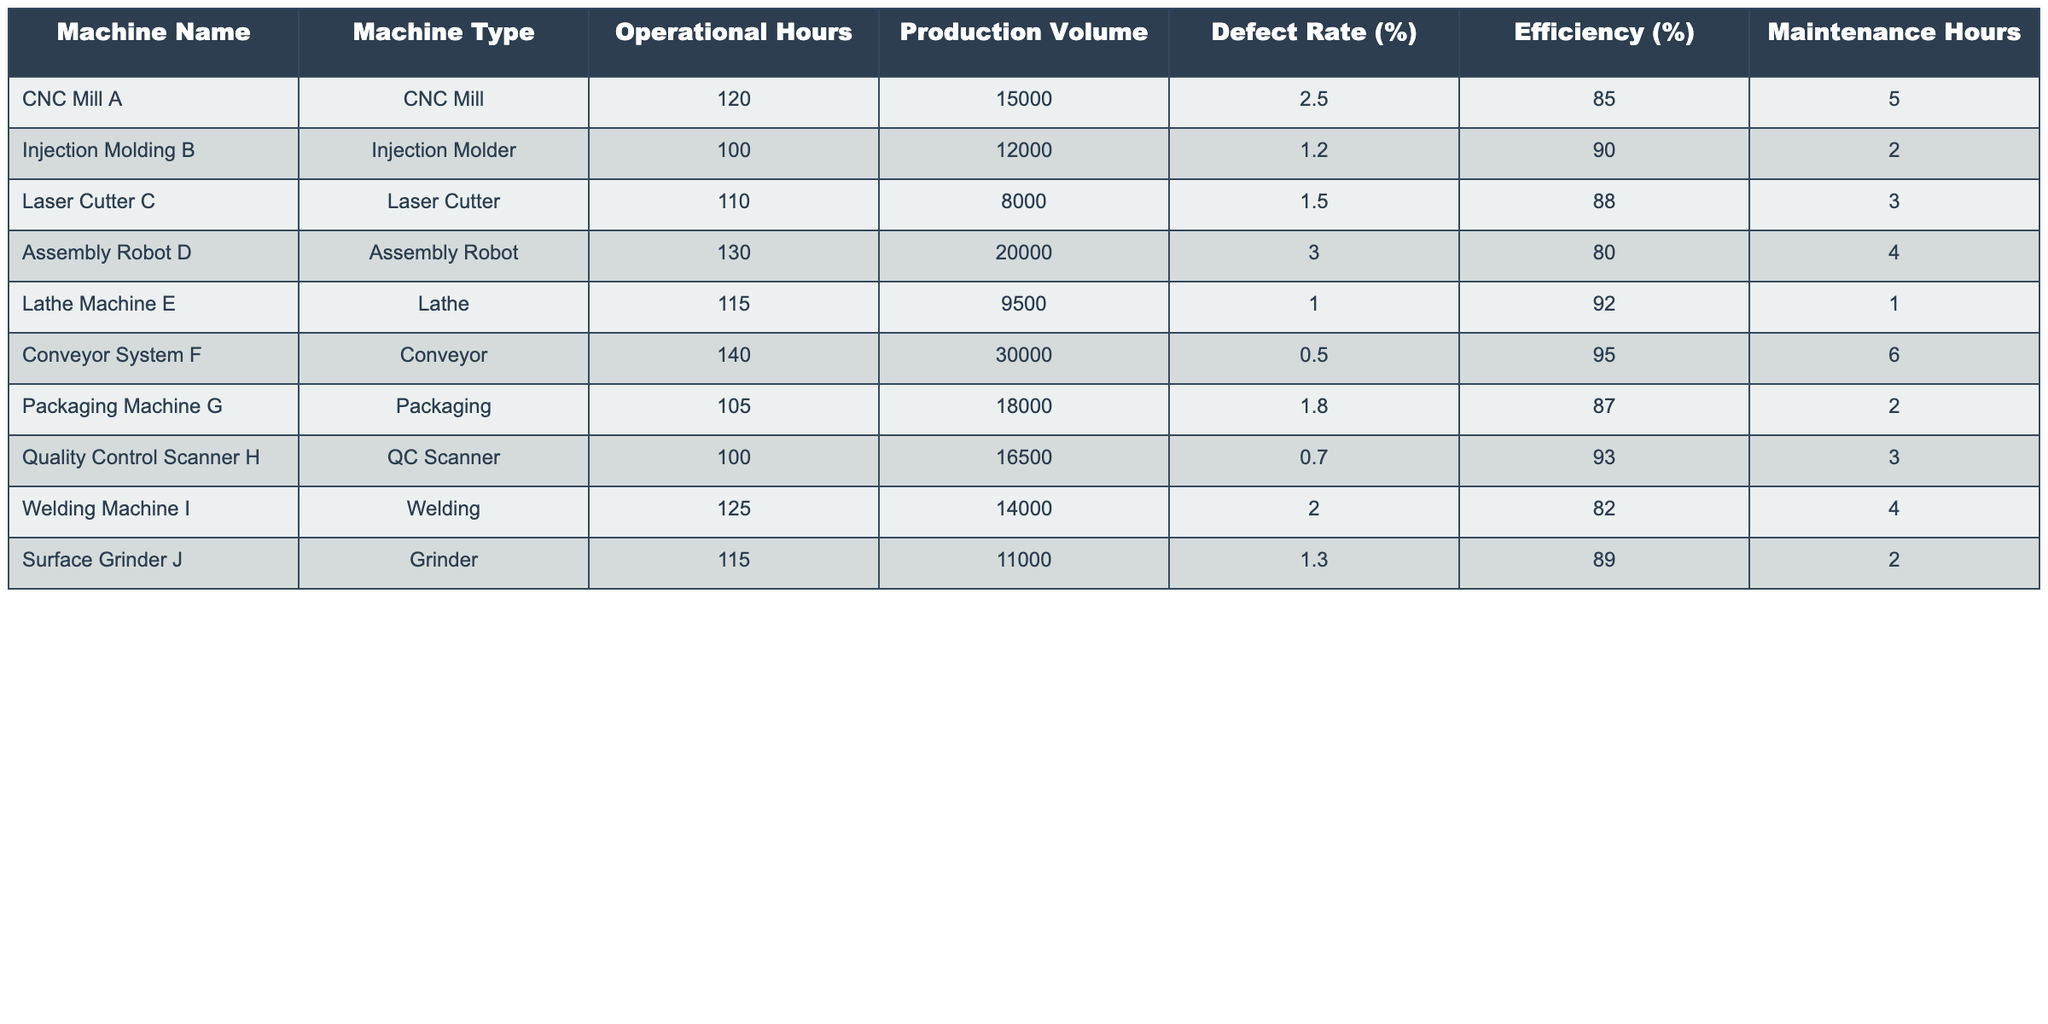What is the Efficiency percentage of the Conveyor System F? According to the table, the Efficiency percentage of Conveyor System F is listed directly under the Efficiency (%) column. It shows 95%.
Answer: 95% Which machine has the highest Production Volume? By looking at the Production Volume column, Conveyor System F has the highest production value of 30,000 units compared to the others.
Answer: Conveyor System F What is the average Defect Rate of all machines on the production line? The Defect Rates are: 2.5, 1.2, 1.5, 3.0, 1.0, 0.5, 1.8, 0.7, 2.0, 1.3. Summing these gives 16.5. There are 10 machines, so the average is 16.5/10 = 1.65%.
Answer: 1.65% Is the Defect Rate of Lathe Machine E lower than the average Defect Rate? The Defect Rate for Lathe Machine E is 1.0%. From the previous question, the average Defect Rate is 1.65%, and since 1.0% is less than 1.65%, the statement is true.
Answer: Yes Which machine uses the most Maintenance Hours? Looking at the Maintenance Hours column, the Conveyor System F has the highest value of 6 hours among all machines.
Answer: Conveyor System F If you compare the average Efficiency of CNC Mill A and Injection Molding B, which one is more efficient? The Efficiency of CNC Mill A is 85%, and for Injection Molding B, it's 90%. The average of the two is (85 + 90) / 2 = 87.5%. Since Injection Molding B has a higher percentage, it is more efficient.
Answer: Injection Molding B What is the total Operational Hours of the machines with the lowest Defect Rates? The machines with the lowest Defect Rates are Conveyor System F (0.5%), Quality Control Scanner H (0.7%), and Injection Molding B (1.2%). Their Operational Hours are 140, 100, and 100, respectively. Summing these gives 140 + 100 + 100 = 340 hours.
Answer: 340 Is the Production Volume of Assembly Robot D greater than the average Production Volume of all machines? The Production Volumes are: 15,000, 12,000, 8,000, 20,000, 9,500, 30,000, 18,000, 16,500, 14,000, and 11,000. The sum is  150,000 units. There are 10 machines, so the average is 150,000 / 10 = 15,000. The Assembly Robot D has a production of 20,000, which is greater than 15,000.
Answer: Yes What is the difference in Efficiency % between the best and worst performing machines? The best Efficiency % is the Conveyor System F at 95%, and the worst is Assembly Robot D at 80%. The difference is 95% - 80% = 15%.
Answer: 15% 